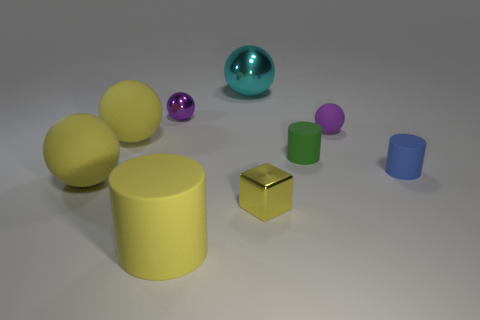Subtract all cyan spheres. How many spheres are left? 4 Subtract all big cyan shiny balls. How many balls are left? 4 Subtract all blue spheres. Subtract all gray cylinders. How many spheres are left? 5 Add 1 blue objects. How many objects exist? 10 Subtract all cylinders. How many objects are left? 6 Subtract 0 blue cubes. How many objects are left? 9 Subtract all tiny gray cylinders. Subtract all tiny spheres. How many objects are left? 7 Add 1 blue things. How many blue things are left? 2 Add 8 tiny rubber balls. How many tiny rubber balls exist? 9 